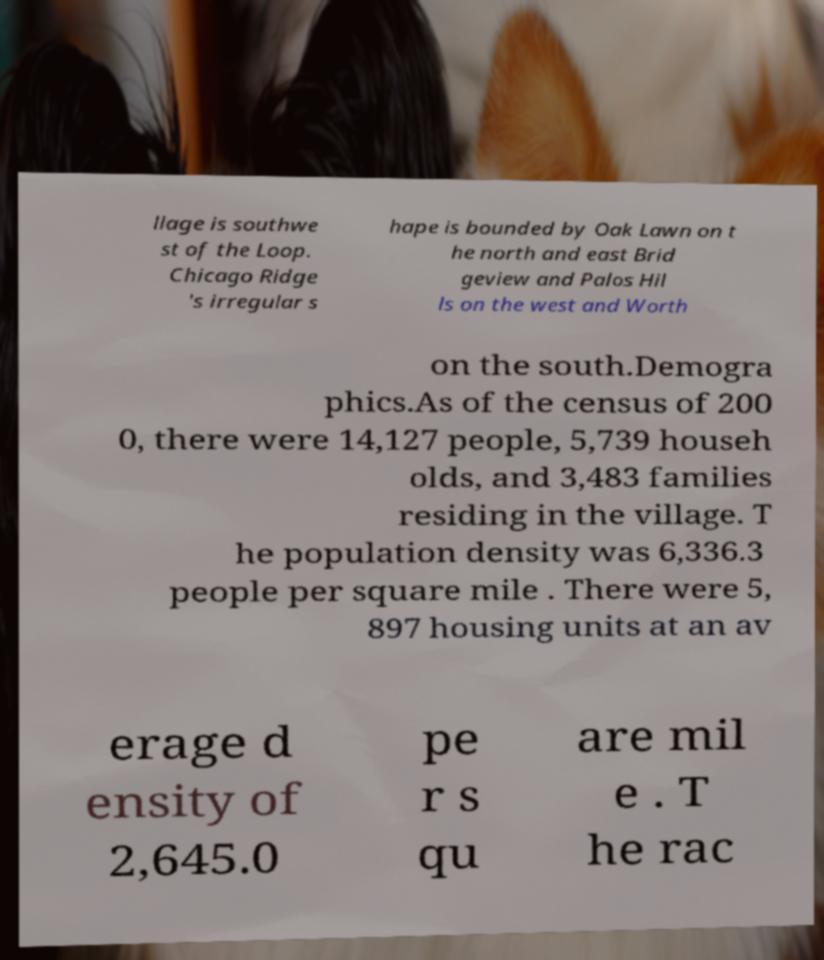I need the written content from this picture converted into text. Can you do that? llage is southwe st of the Loop. Chicago Ridge 's irregular s hape is bounded by Oak Lawn on t he north and east Brid geview and Palos Hil ls on the west and Worth on the south.Demogra phics.As of the census of 200 0, there were 14,127 people, 5,739 househ olds, and 3,483 families residing in the village. T he population density was 6,336.3 people per square mile . There were 5, 897 housing units at an av erage d ensity of 2,645.0 pe r s qu are mil e . T he rac 